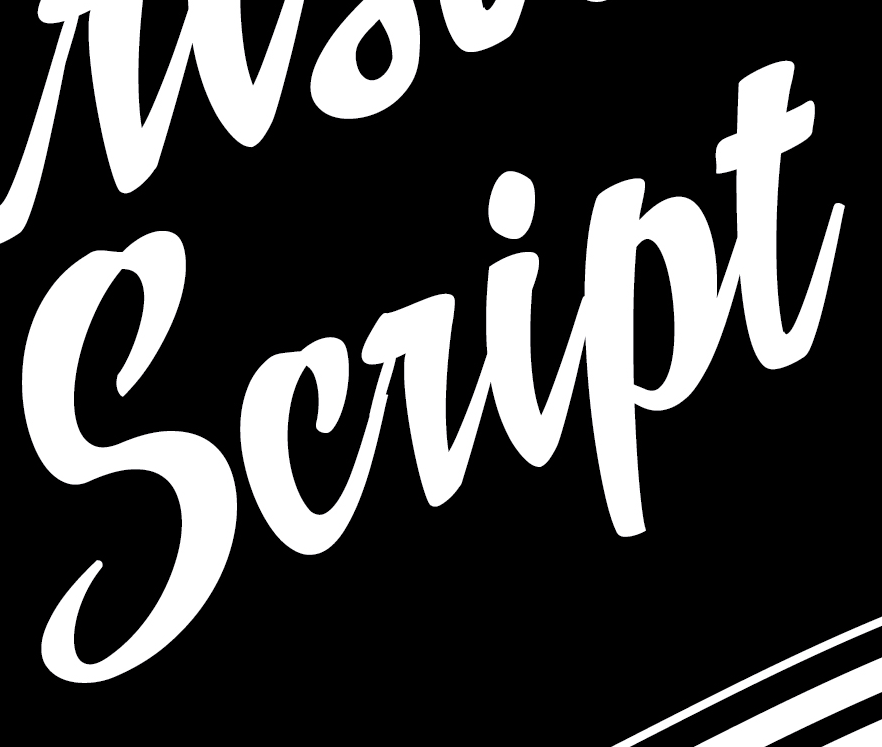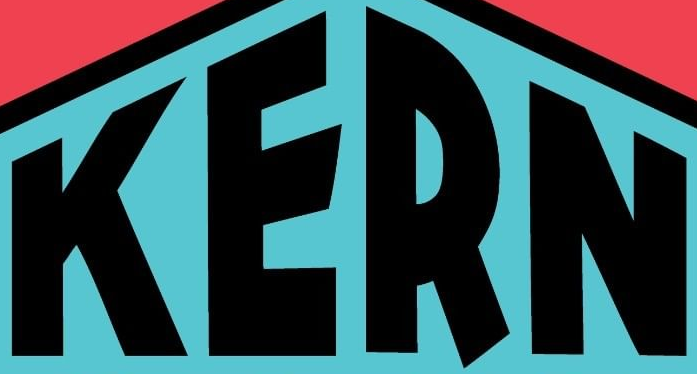What text is displayed in these images sequentially, separated by a semicolon? script; KERN 